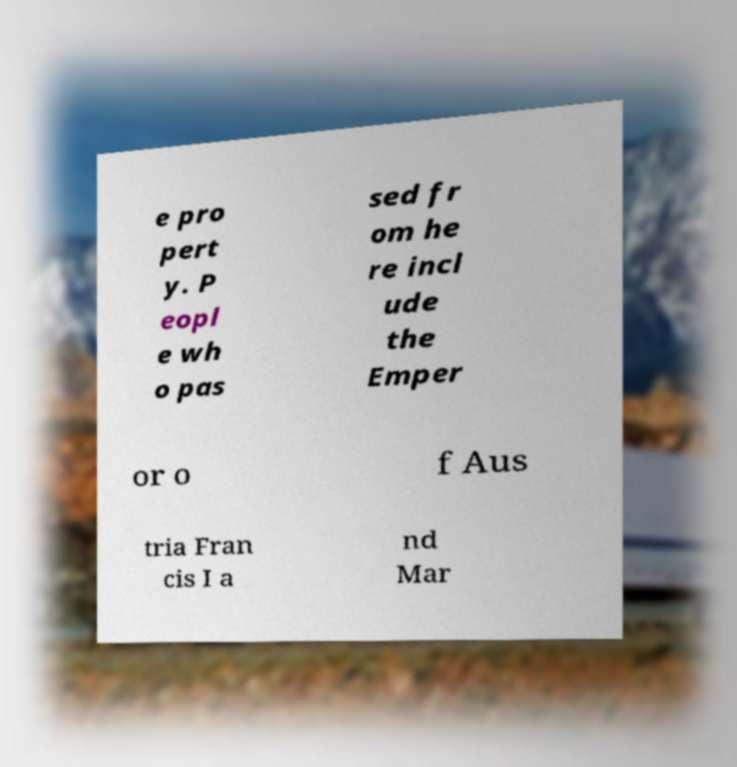Can you read and provide the text displayed in the image?This photo seems to have some interesting text. Can you extract and type it out for me? e pro pert y. P eopl e wh o pas sed fr om he re incl ude the Emper or o f Aus tria Fran cis I a nd Mar 